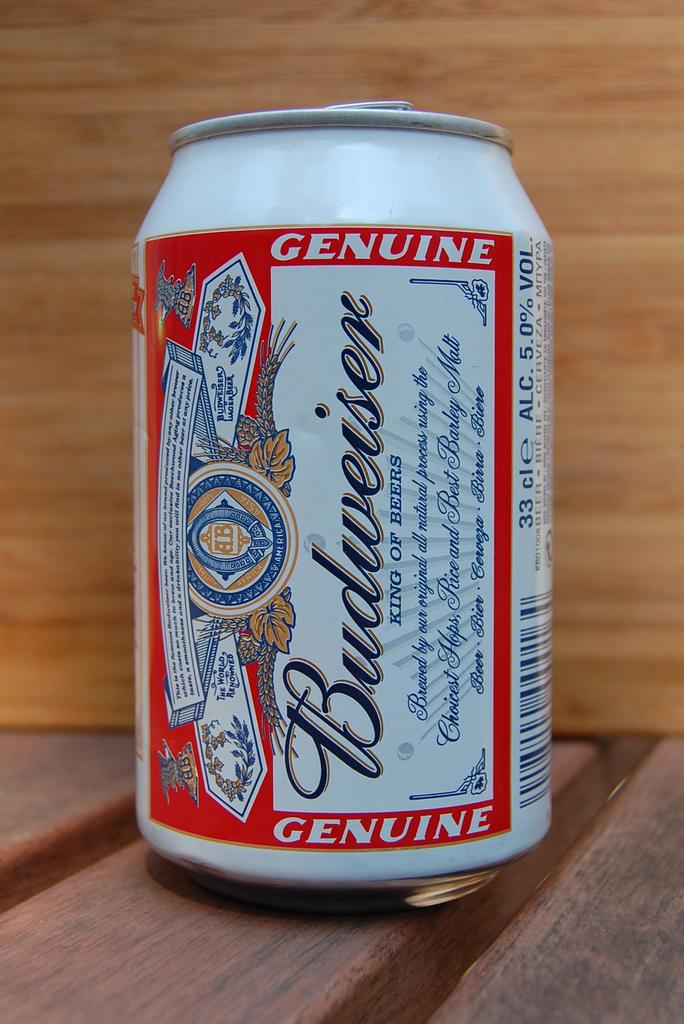Provide a one-sentence caption for the provided image. A can of beer made by Budweiser sits atop a wood surface. 